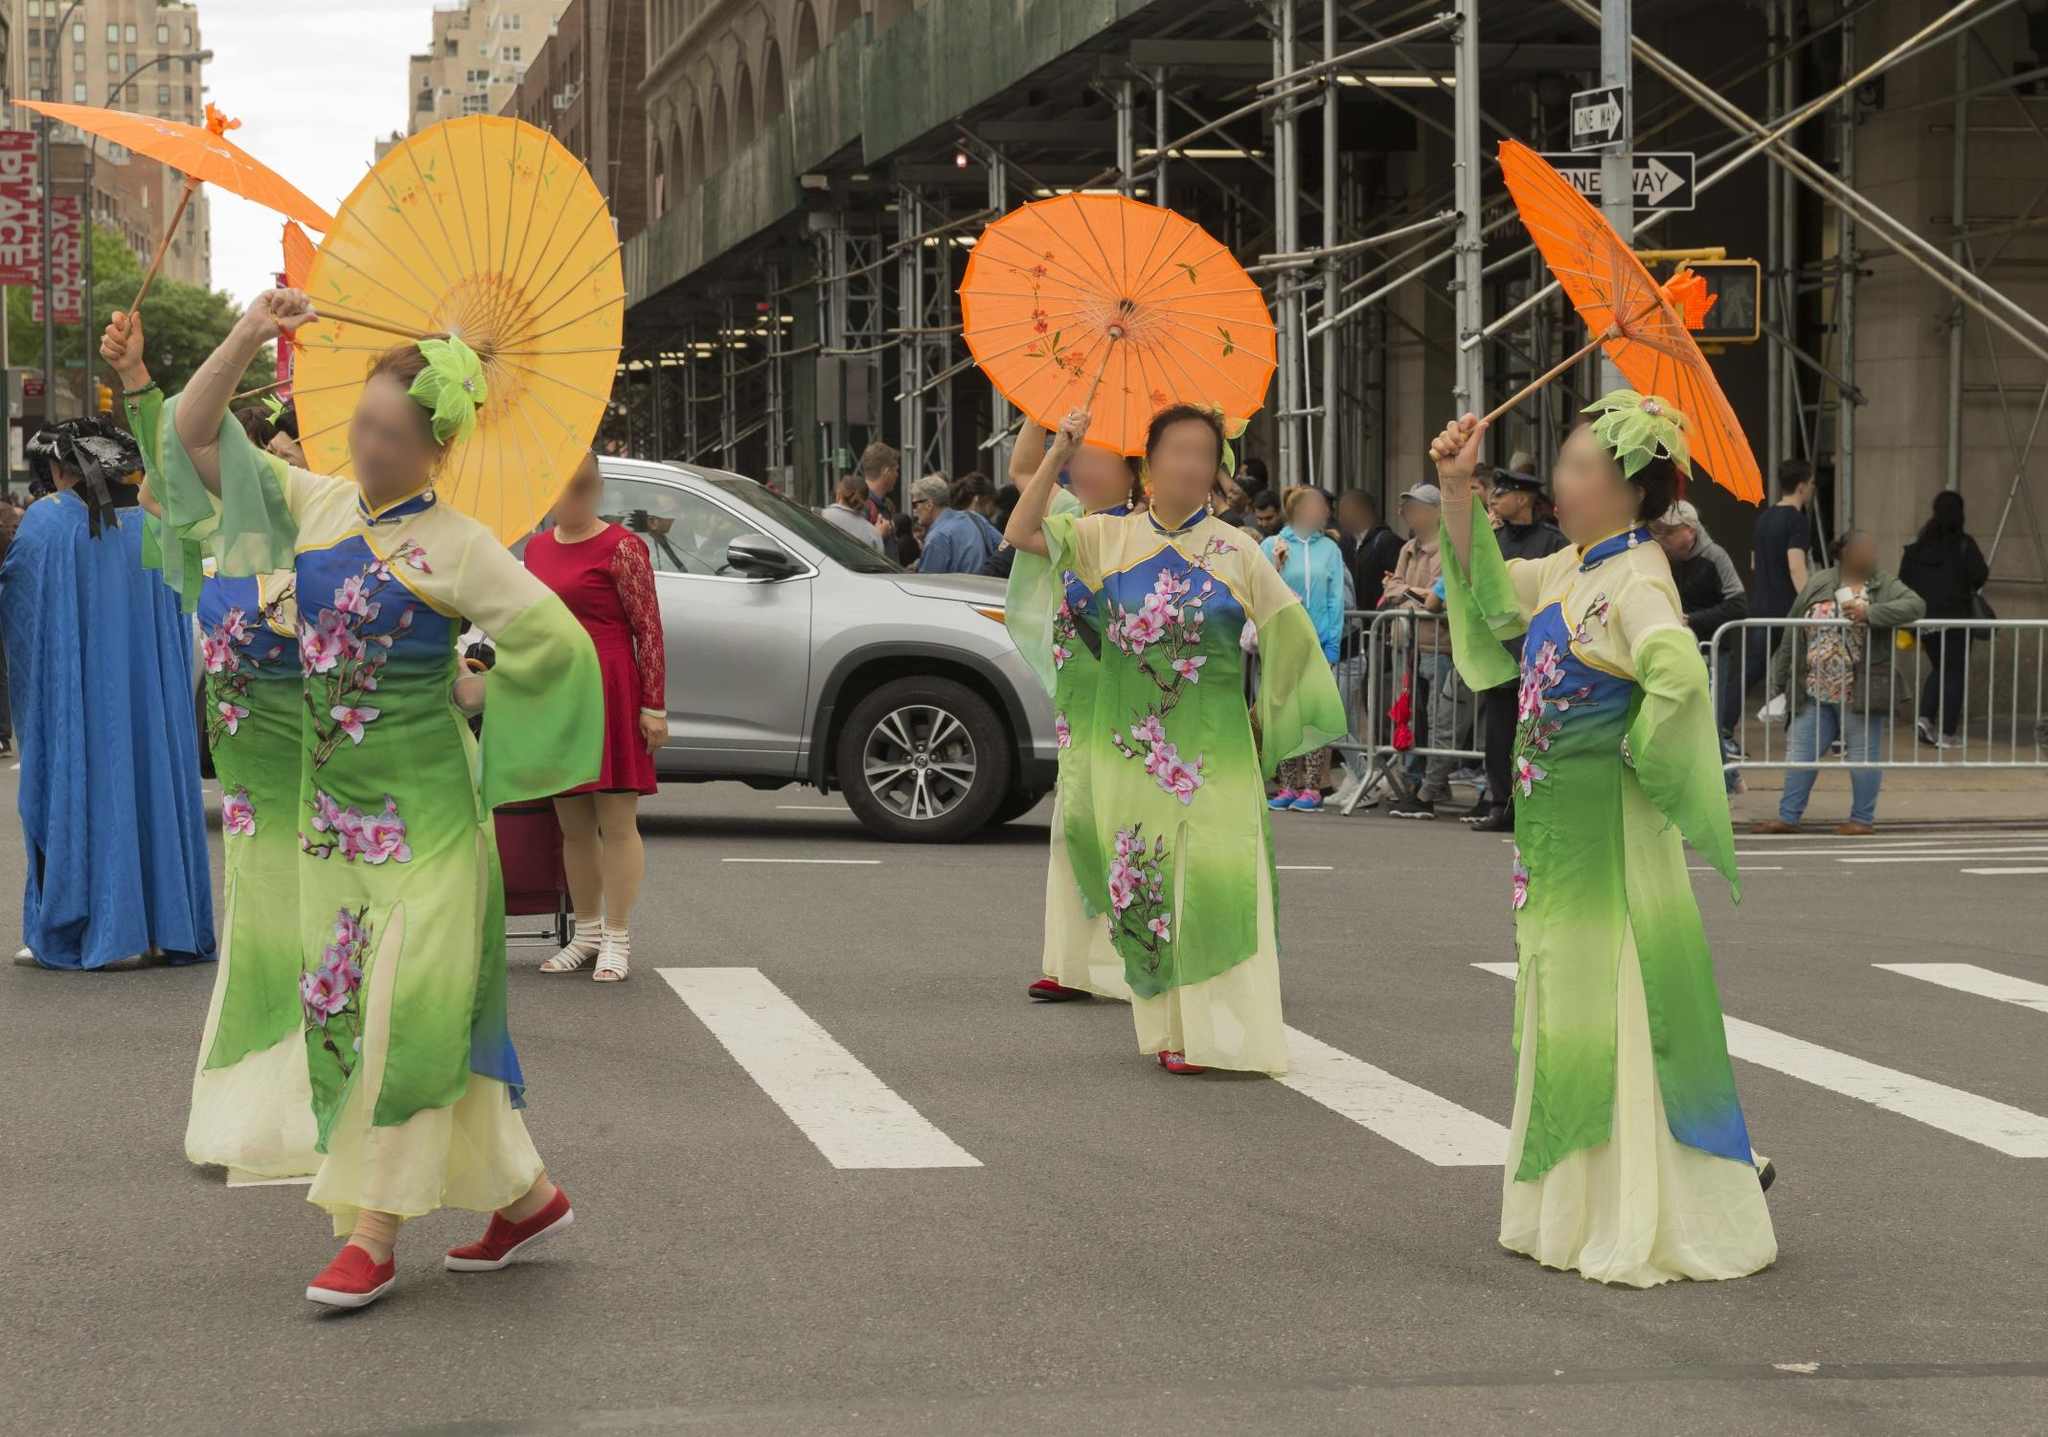What modern elements contrast with the traditional attire in the image? The image presents a fascinating juxtaposition of traditional and modern elements. The women in their traditional kimonos, with intricate floral patterns and parasols, stand in contrast to the modern urban backdrop. The city street, lined with scaffolding and contemporary buildings, as well as the parked car and the casually dressed onlookers, represent the mundanity and functionality of modern life. This blend of old and new highlights the coexistence and harmony of cultural heritage in a rapidly advancing world. The scene captures the essence of cultural preservation amidst modernity. The traditional kimonos and parasols are contrasted by the urban environment, characterized by tall buildings, metal scaffolding, and a modern car. The crowd, dressed in everyday attire, serves as a reminder of today's lifestyle. This mix of elements showcases the dynamic interplay of tradition and modernity in contemporary society. 